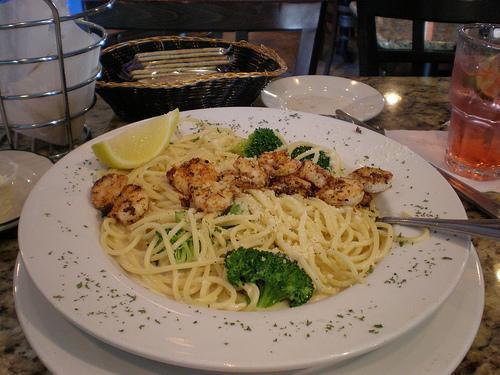How many forks are in the picture?
Give a very brief answer. 1. 